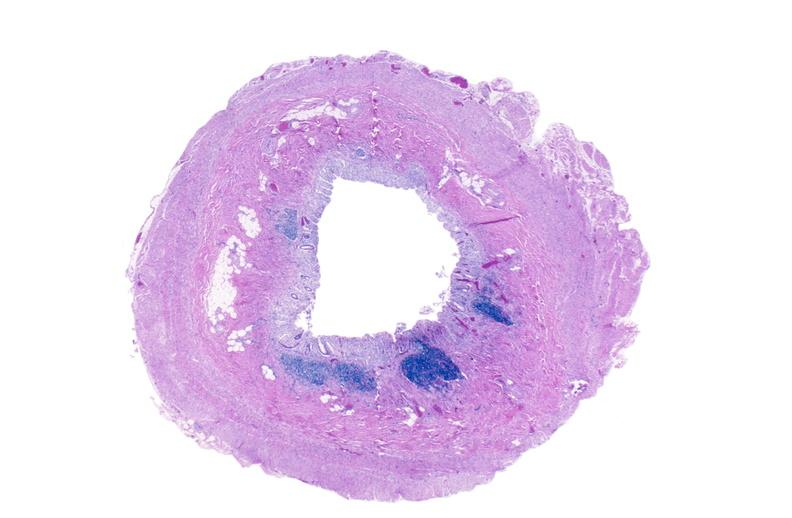s this photo of infant from head to toe present?
Answer the question using a single word or phrase. No 